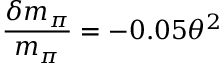<formula> <loc_0><loc_0><loc_500><loc_500>\frac { \delta m _ { \pi } } { m _ { \pi } } = - 0 . 0 5 \theta ^ { 2 }</formula> 